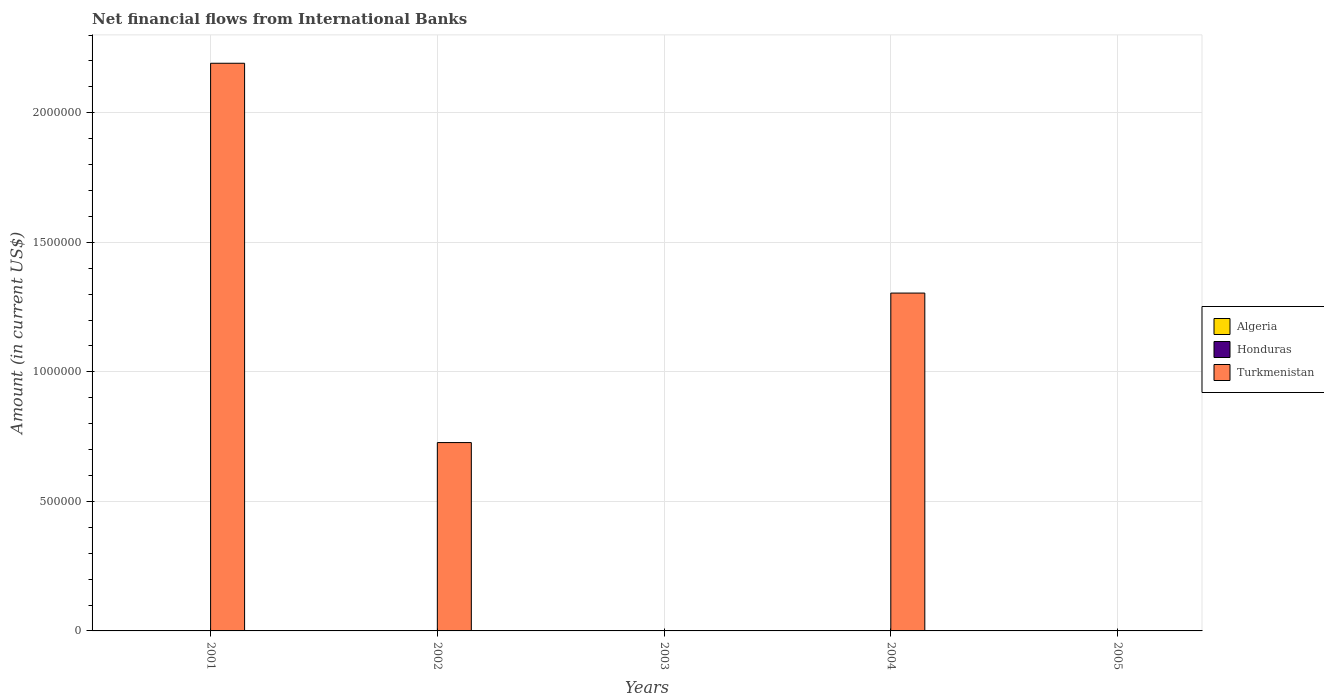How many different coloured bars are there?
Give a very brief answer. 1. Are the number of bars per tick equal to the number of legend labels?
Your answer should be compact. No. How many bars are there on the 4th tick from the right?
Your response must be concise. 1. What is the net financial aid flows in Turkmenistan in 2001?
Your answer should be compact. 2.19e+06. Across all years, what is the maximum net financial aid flows in Turkmenistan?
Your response must be concise. 2.19e+06. Across all years, what is the minimum net financial aid flows in Turkmenistan?
Your answer should be compact. 0. What is the total net financial aid flows in Turkmenistan in the graph?
Ensure brevity in your answer.  4.22e+06. What is the difference between the net financial aid flows in Algeria in 2003 and the net financial aid flows in Turkmenistan in 2001?
Provide a succinct answer. -2.19e+06. In how many years, is the net financial aid flows in Algeria greater than 500000 US$?
Provide a succinct answer. 0. What is the difference between the highest and the second highest net financial aid flows in Turkmenistan?
Give a very brief answer. 8.87e+05. What is the difference between the highest and the lowest net financial aid flows in Turkmenistan?
Offer a very short reply. 2.19e+06. Is the sum of the net financial aid flows in Turkmenistan in 2001 and 2004 greater than the maximum net financial aid flows in Honduras across all years?
Your answer should be very brief. Yes. Are all the bars in the graph horizontal?
Make the answer very short. No. How many years are there in the graph?
Keep it short and to the point. 5. What is the difference between two consecutive major ticks on the Y-axis?
Your answer should be compact. 5.00e+05. Are the values on the major ticks of Y-axis written in scientific E-notation?
Give a very brief answer. No. Does the graph contain grids?
Offer a terse response. Yes. Where does the legend appear in the graph?
Make the answer very short. Center right. How many legend labels are there?
Your answer should be compact. 3. How are the legend labels stacked?
Provide a succinct answer. Vertical. What is the title of the graph?
Your response must be concise. Net financial flows from International Banks. Does "India" appear as one of the legend labels in the graph?
Your answer should be very brief. No. What is the label or title of the X-axis?
Give a very brief answer. Years. What is the Amount (in current US$) in Algeria in 2001?
Ensure brevity in your answer.  0. What is the Amount (in current US$) of Honduras in 2001?
Keep it short and to the point. 0. What is the Amount (in current US$) in Turkmenistan in 2001?
Provide a short and direct response. 2.19e+06. What is the Amount (in current US$) of Turkmenistan in 2002?
Ensure brevity in your answer.  7.27e+05. What is the Amount (in current US$) in Algeria in 2004?
Ensure brevity in your answer.  0. What is the Amount (in current US$) of Honduras in 2004?
Make the answer very short. 0. What is the Amount (in current US$) of Turkmenistan in 2004?
Give a very brief answer. 1.30e+06. What is the Amount (in current US$) in Algeria in 2005?
Your response must be concise. 0. Across all years, what is the maximum Amount (in current US$) in Turkmenistan?
Your answer should be very brief. 2.19e+06. What is the total Amount (in current US$) of Algeria in the graph?
Your answer should be very brief. 0. What is the total Amount (in current US$) in Turkmenistan in the graph?
Provide a short and direct response. 4.22e+06. What is the difference between the Amount (in current US$) of Turkmenistan in 2001 and that in 2002?
Your answer should be compact. 1.46e+06. What is the difference between the Amount (in current US$) of Turkmenistan in 2001 and that in 2004?
Ensure brevity in your answer.  8.87e+05. What is the difference between the Amount (in current US$) in Turkmenistan in 2002 and that in 2004?
Ensure brevity in your answer.  -5.77e+05. What is the average Amount (in current US$) of Turkmenistan per year?
Ensure brevity in your answer.  8.44e+05. What is the ratio of the Amount (in current US$) in Turkmenistan in 2001 to that in 2002?
Offer a terse response. 3.01. What is the ratio of the Amount (in current US$) of Turkmenistan in 2001 to that in 2004?
Ensure brevity in your answer.  1.68. What is the ratio of the Amount (in current US$) in Turkmenistan in 2002 to that in 2004?
Keep it short and to the point. 0.56. What is the difference between the highest and the second highest Amount (in current US$) in Turkmenistan?
Provide a succinct answer. 8.87e+05. What is the difference between the highest and the lowest Amount (in current US$) in Turkmenistan?
Give a very brief answer. 2.19e+06. 